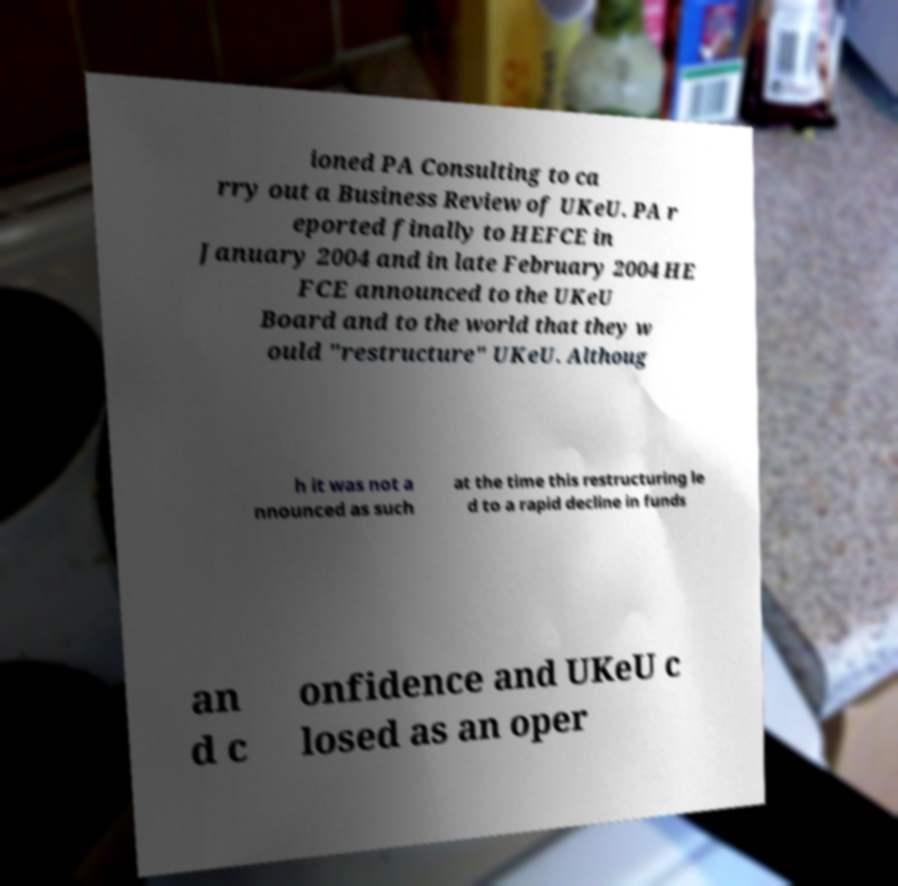Please identify and transcribe the text found in this image. ioned PA Consulting to ca rry out a Business Review of UKeU. PA r eported finally to HEFCE in January 2004 and in late February 2004 HE FCE announced to the UKeU Board and to the world that they w ould "restructure" UKeU. Althoug h it was not a nnounced as such at the time this restructuring le d to a rapid decline in funds an d c onfidence and UKeU c losed as an oper 